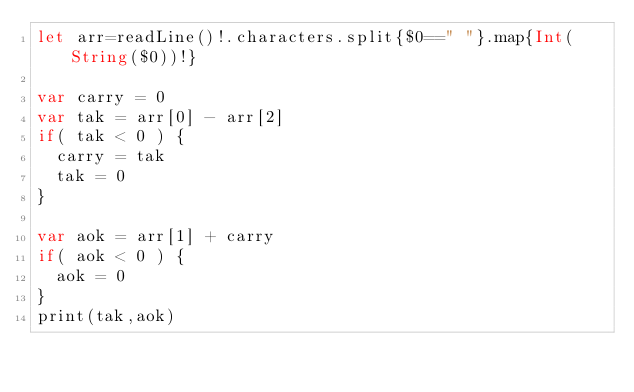<code> <loc_0><loc_0><loc_500><loc_500><_Swift_>let arr=readLine()!.characters.split{$0==" "}.map{Int(String($0))!}

var carry = 0
var tak = arr[0] - arr[2]
if( tak < 0 ) {
  carry = tak
  tak = 0
}

var aok = arr[1] + carry
if( aok < 0 ) {
  aok = 0
}
print(tak,aok)</code> 